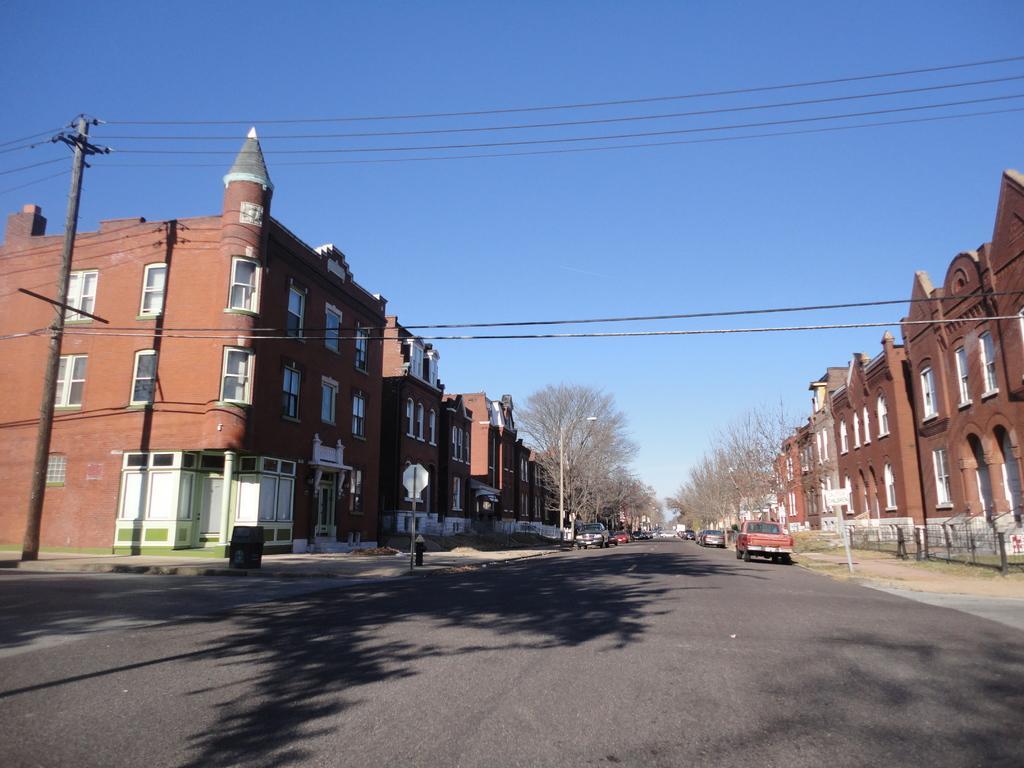In one or two sentences, can you explain what this image depicts? This is an outside view. At the bottom there is a road and I can see few vehicles on the road. On both sides of this road there are many trees, buildings and also there are few poles along with the cables. At the top of the image I can see the sky in blue color. 